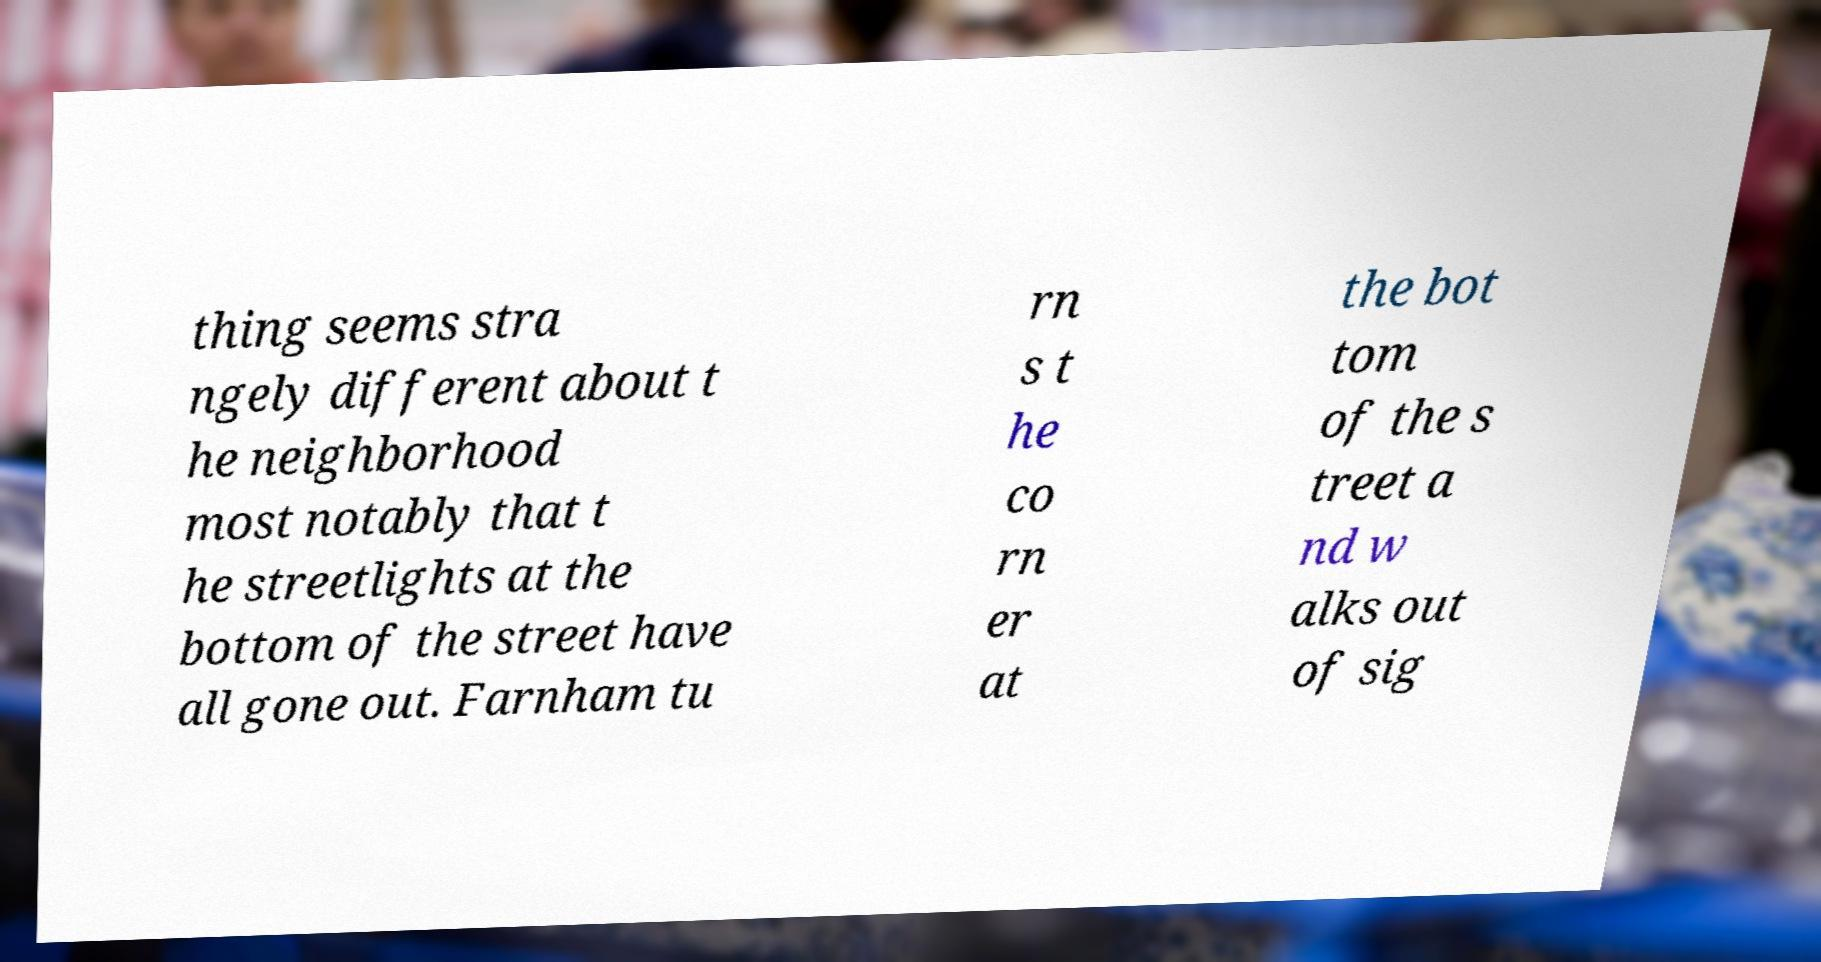Please read and relay the text visible in this image. What does it say? thing seems stra ngely different about t he neighborhood most notably that t he streetlights at the bottom of the street have all gone out. Farnham tu rn s t he co rn er at the bot tom of the s treet a nd w alks out of sig 